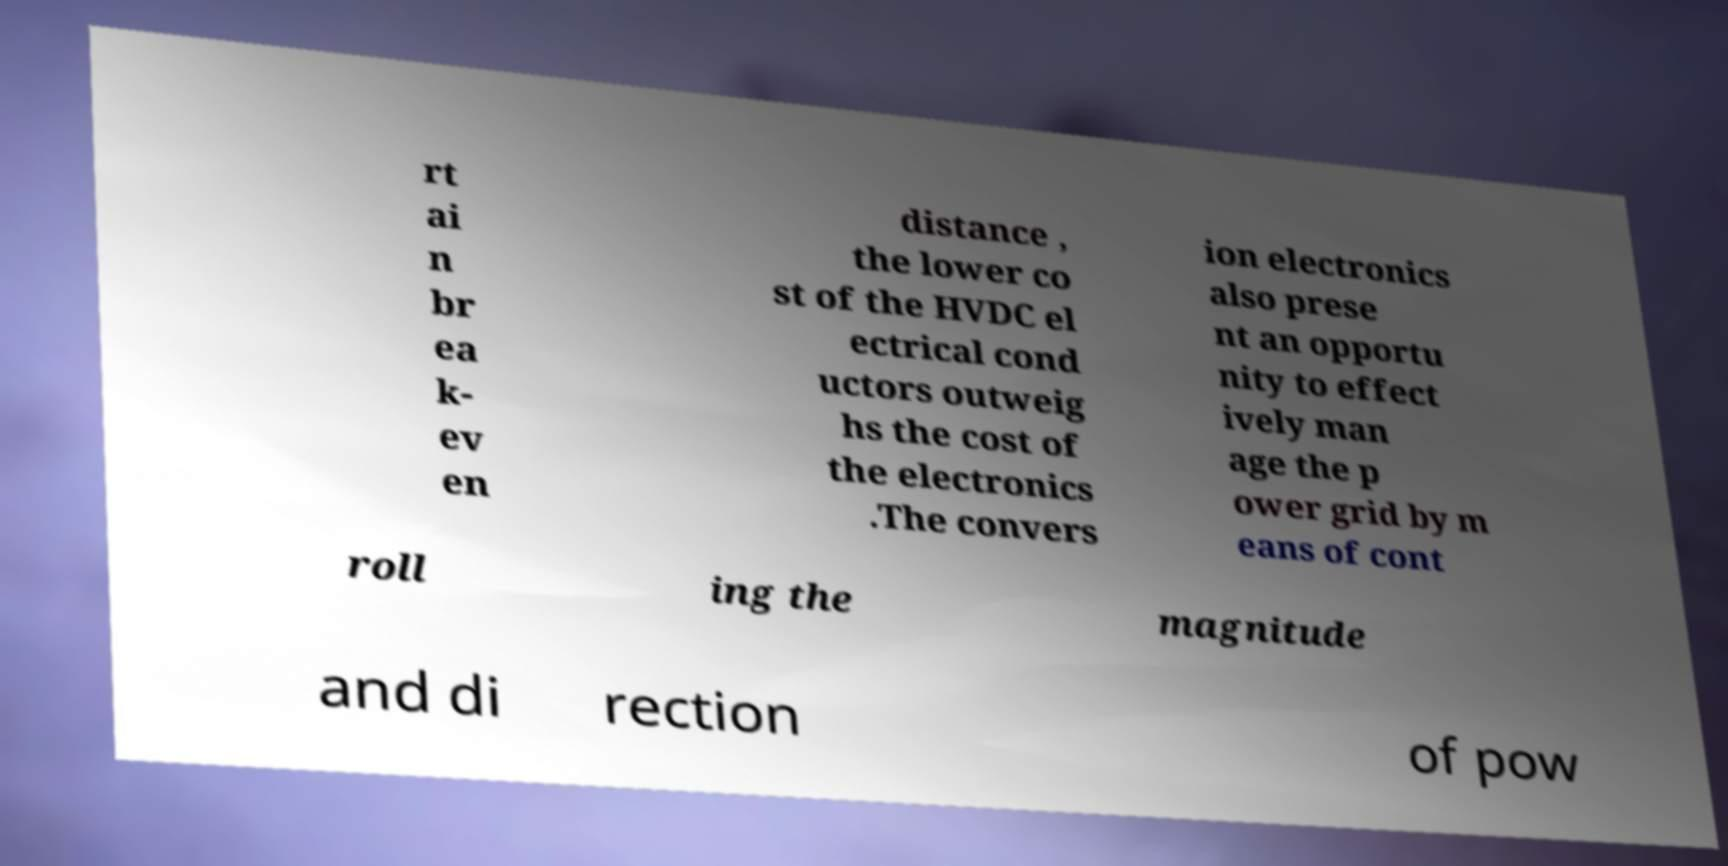I need the written content from this picture converted into text. Can you do that? rt ai n br ea k- ev en distance , the lower co st of the HVDC el ectrical cond uctors outweig hs the cost of the electronics .The convers ion electronics also prese nt an opportu nity to effect ively man age the p ower grid by m eans of cont roll ing the magnitude and di rection of pow 